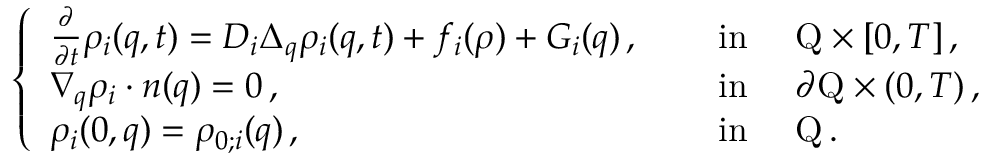<formula> <loc_0><loc_0><loc_500><loc_500>\left \{ \begin{array} { l l } { \frac { \partial } { \partial t } \rho _ { i } ( q , t ) = D _ { i } \Delta _ { q } \rho _ { i } ( q , t ) + f _ { i } ( \rho ) + G _ { i } ( q ) \, , } & { \quad i n \quad Q \times [ 0 , T ] \, , } \\ { \nabla _ { q } \rho _ { i } \cdot n ( q ) = 0 \, , } & { \quad i n \quad \partial Q \times ( 0 , T ) \, , } \\ { \rho _ { i } ( 0 , q ) = \rho _ { 0 ; i } ( q ) \, , } & { \quad i n \quad Q \, . } \end{array}</formula> 